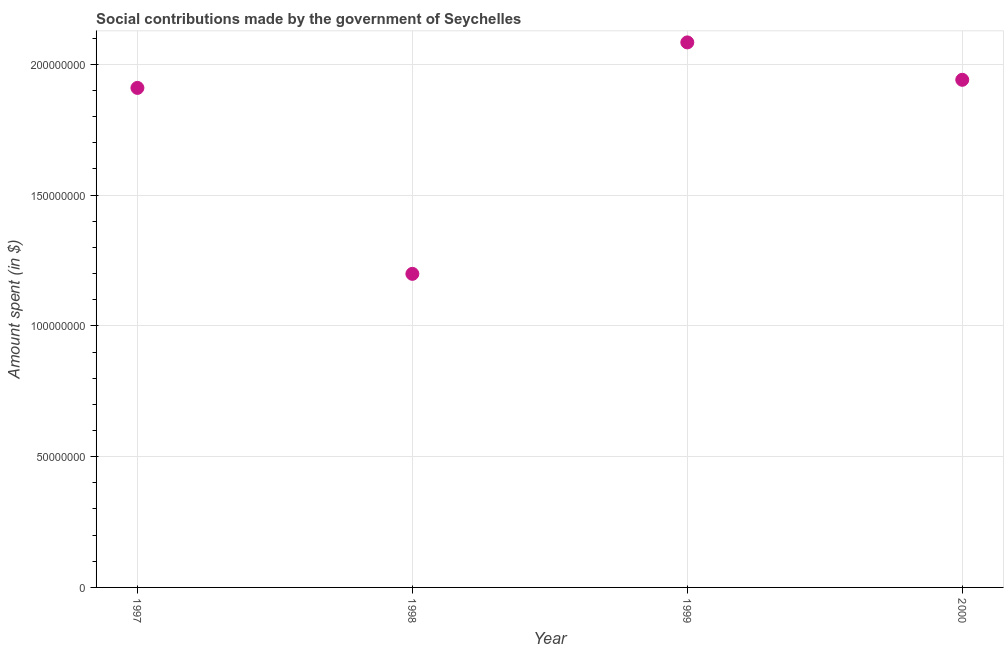What is the amount spent in making social contributions in 2000?
Offer a terse response. 1.94e+08. Across all years, what is the maximum amount spent in making social contributions?
Offer a terse response. 2.08e+08. Across all years, what is the minimum amount spent in making social contributions?
Offer a very short reply. 1.20e+08. In which year was the amount spent in making social contributions maximum?
Offer a very short reply. 1999. In which year was the amount spent in making social contributions minimum?
Your answer should be very brief. 1998. What is the sum of the amount spent in making social contributions?
Ensure brevity in your answer.  7.13e+08. What is the difference between the amount spent in making social contributions in 1997 and 2000?
Ensure brevity in your answer.  -3.10e+06. What is the average amount spent in making social contributions per year?
Ensure brevity in your answer.  1.78e+08. What is the median amount spent in making social contributions?
Keep it short and to the point. 1.93e+08. In how many years, is the amount spent in making social contributions greater than 10000000 $?
Offer a terse response. 4. Do a majority of the years between 2000 and 1999 (inclusive) have amount spent in making social contributions greater than 80000000 $?
Provide a succinct answer. No. What is the ratio of the amount spent in making social contributions in 1998 to that in 2000?
Keep it short and to the point. 0.62. What is the difference between the highest and the second highest amount spent in making social contributions?
Offer a very short reply. 1.43e+07. Is the sum of the amount spent in making social contributions in 1998 and 2000 greater than the maximum amount spent in making social contributions across all years?
Offer a terse response. Yes. What is the difference between the highest and the lowest amount spent in making social contributions?
Your answer should be very brief. 8.85e+07. In how many years, is the amount spent in making social contributions greater than the average amount spent in making social contributions taken over all years?
Ensure brevity in your answer.  3. Does the amount spent in making social contributions monotonically increase over the years?
Offer a very short reply. No. How many dotlines are there?
Offer a very short reply. 1. How many years are there in the graph?
Give a very brief answer. 4. What is the difference between two consecutive major ticks on the Y-axis?
Your answer should be compact. 5.00e+07. Are the values on the major ticks of Y-axis written in scientific E-notation?
Your answer should be very brief. No. Does the graph contain any zero values?
Make the answer very short. No. What is the title of the graph?
Make the answer very short. Social contributions made by the government of Seychelles. What is the label or title of the Y-axis?
Ensure brevity in your answer.  Amount spent (in $). What is the Amount spent (in $) in 1997?
Make the answer very short. 1.91e+08. What is the Amount spent (in $) in 1998?
Your response must be concise. 1.20e+08. What is the Amount spent (in $) in 1999?
Your answer should be compact. 2.08e+08. What is the Amount spent (in $) in 2000?
Ensure brevity in your answer.  1.94e+08. What is the difference between the Amount spent (in $) in 1997 and 1998?
Provide a succinct answer. 7.11e+07. What is the difference between the Amount spent (in $) in 1997 and 1999?
Offer a terse response. -1.74e+07. What is the difference between the Amount spent (in $) in 1997 and 2000?
Your response must be concise. -3.10e+06. What is the difference between the Amount spent (in $) in 1998 and 1999?
Keep it short and to the point. -8.85e+07. What is the difference between the Amount spent (in $) in 1998 and 2000?
Offer a terse response. -7.42e+07. What is the difference between the Amount spent (in $) in 1999 and 2000?
Give a very brief answer. 1.43e+07. What is the ratio of the Amount spent (in $) in 1997 to that in 1998?
Provide a short and direct response. 1.59. What is the ratio of the Amount spent (in $) in 1997 to that in 1999?
Keep it short and to the point. 0.92. What is the ratio of the Amount spent (in $) in 1997 to that in 2000?
Provide a succinct answer. 0.98. What is the ratio of the Amount spent (in $) in 1998 to that in 1999?
Give a very brief answer. 0.57. What is the ratio of the Amount spent (in $) in 1998 to that in 2000?
Your answer should be very brief. 0.62. What is the ratio of the Amount spent (in $) in 1999 to that in 2000?
Your answer should be very brief. 1.07. 